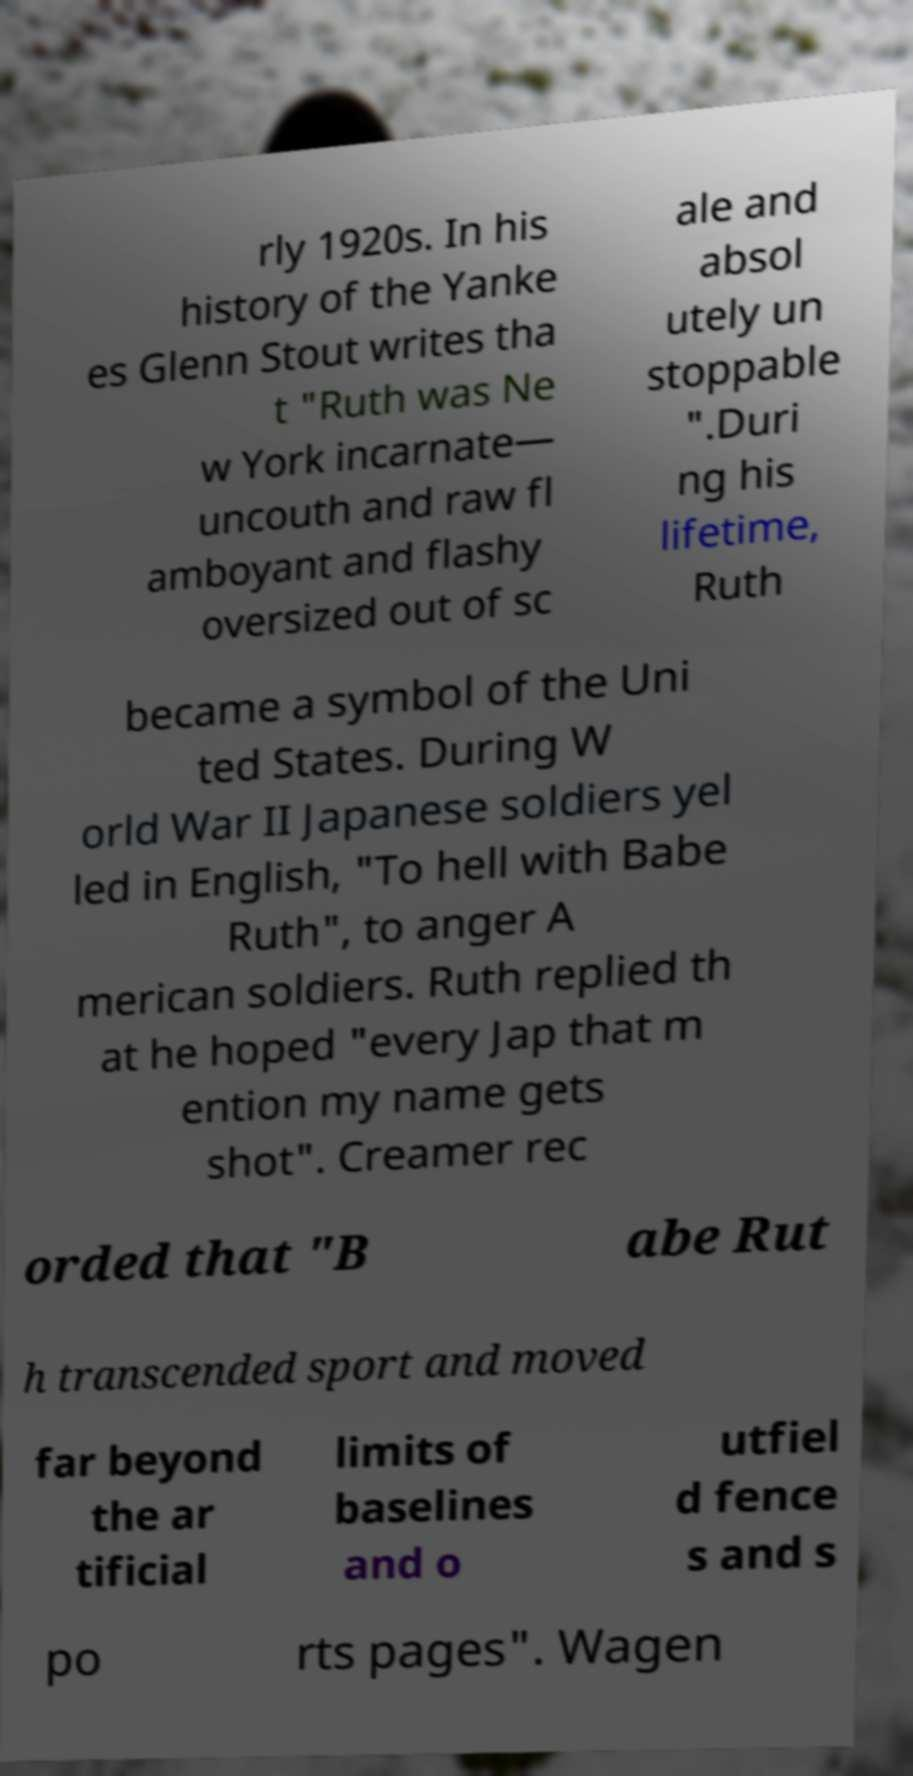What messages or text are displayed in this image? I need them in a readable, typed format. rly 1920s. In his history of the Yanke es Glenn Stout writes tha t "Ruth was Ne w York incarnate— uncouth and raw fl amboyant and flashy oversized out of sc ale and absol utely un stoppable ".Duri ng his lifetime, Ruth became a symbol of the Uni ted States. During W orld War II Japanese soldiers yel led in English, "To hell with Babe Ruth", to anger A merican soldiers. Ruth replied th at he hoped "every Jap that m ention my name gets shot". Creamer rec orded that "B abe Rut h transcended sport and moved far beyond the ar tificial limits of baselines and o utfiel d fence s and s po rts pages". Wagen 